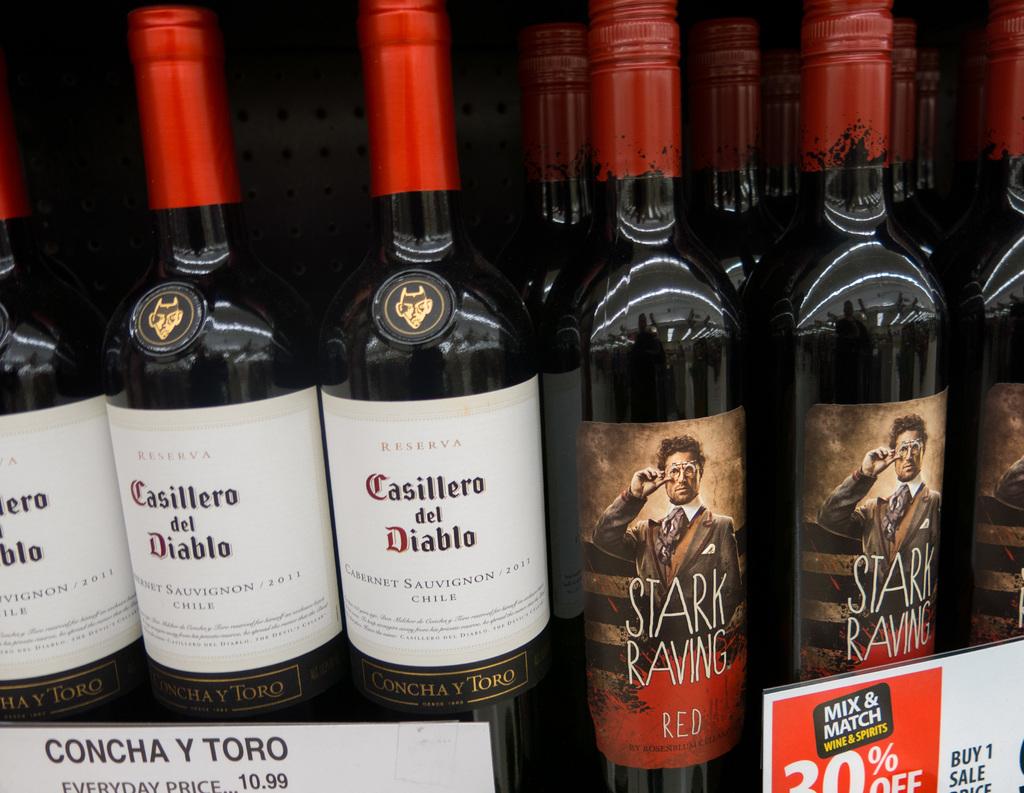What is the price of the wine?
Offer a terse response. 10.99. How much percentage off is shown?
Provide a succinct answer. 30. 